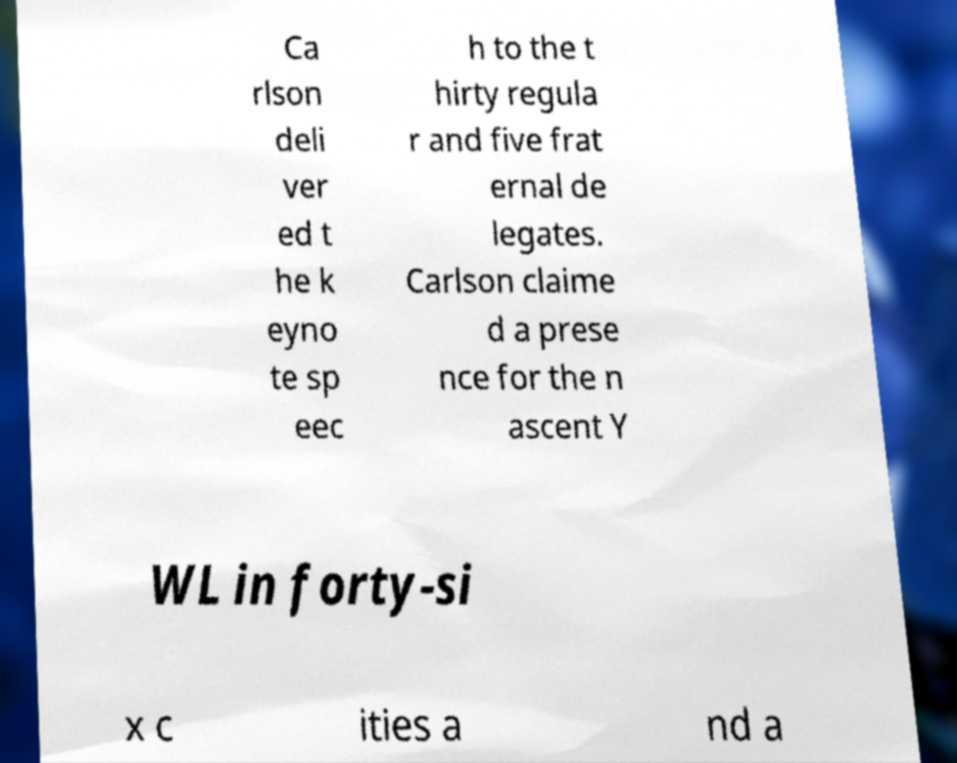Could you extract and type out the text from this image? Ca rlson deli ver ed t he k eyno te sp eec h to the t hirty regula r and five frat ernal de legates. Carlson claime d a prese nce for the n ascent Y WL in forty-si x c ities a nd a 